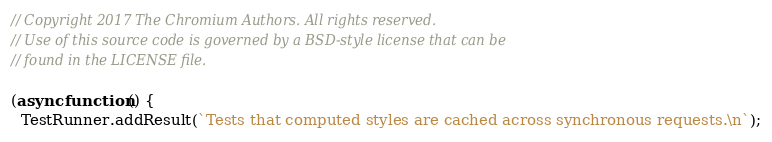<code> <loc_0><loc_0><loc_500><loc_500><_JavaScript_>// Copyright 2017 The Chromium Authors. All rights reserved.
// Use of this source code is governed by a BSD-style license that can be
// found in the LICENSE file.

(async function() {
  TestRunner.addResult(`Tests that computed styles are cached across synchronous requests.\n`);</code> 